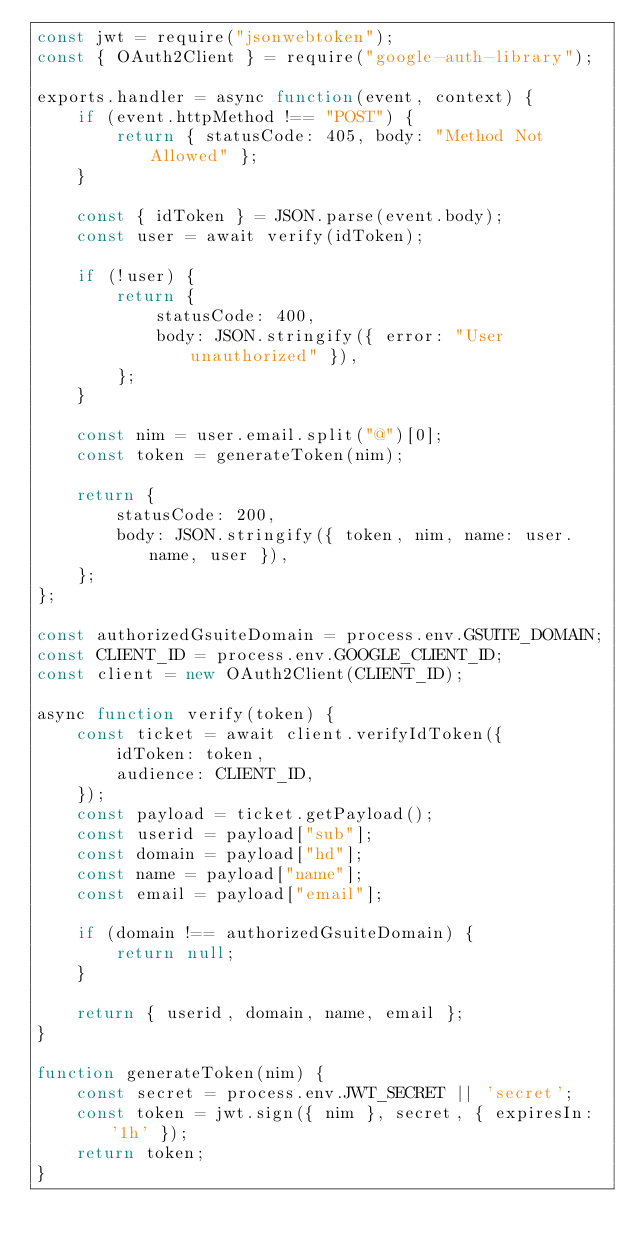Convert code to text. <code><loc_0><loc_0><loc_500><loc_500><_JavaScript_>const jwt = require("jsonwebtoken");
const { OAuth2Client } = require("google-auth-library");

exports.handler = async function(event, context) {
    if (event.httpMethod !== "POST") {
        return { statusCode: 405, body: "Method Not Allowed" };
    }

    const { idToken } = JSON.parse(event.body);
    const user = await verify(idToken);

    if (!user) {
        return {
            statusCode: 400,
            body: JSON.stringify({ error: "User unauthorized" }),
        };
    }

    const nim = user.email.split("@")[0];
    const token = generateToken(nim);

    return {
        statusCode: 200,
        body: JSON.stringify({ token, nim, name: user.name, user }),
    };
};

const authorizedGsuiteDomain = process.env.GSUITE_DOMAIN;
const CLIENT_ID = process.env.GOOGLE_CLIENT_ID;
const client = new OAuth2Client(CLIENT_ID);

async function verify(token) {
    const ticket = await client.verifyIdToken({
        idToken: token,
        audience: CLIENT_ID,
    });
    const payload = ticket.getPayload();
    const userid = payload["sub"];
    const domain = payload["hd"];
    const name = payload["name"];
    const email = payload["email"];

    if (domain !== authorizedGsuiteDomain) {
        return null;
    }

    return { userid, domain, name, email };
}

function generateToken(nim) {
    const secret = process.env.JWT_SECRET || 'secret';
    const token = jwt.sign({ nim }, secret, { expiresIn: '1h' });
    return token;
}</code> 